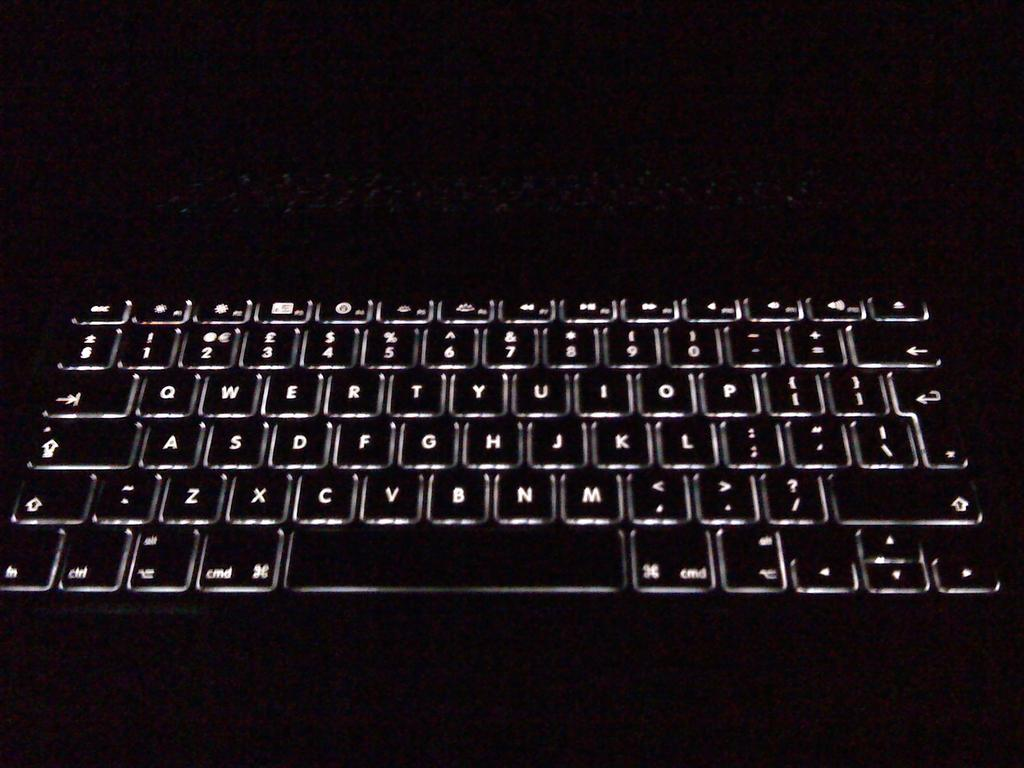<image>
Relay a brief, clear account of the picture shown. A lit up keyboard in the dark that has a 'cmd' button on it. 